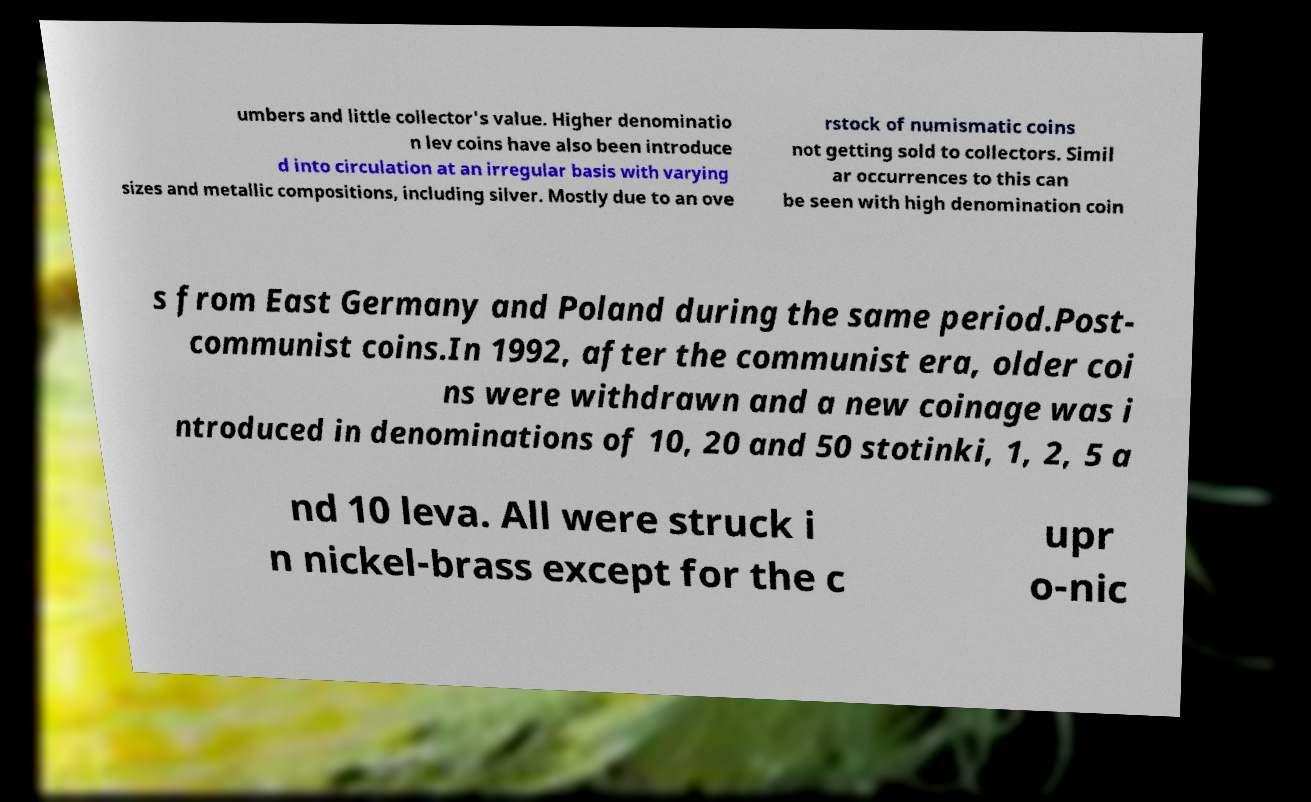Can you read and provide the text displayed in the image?This photo seems to have some interesting text. Can you extract and type it out for me? umbers and little collector's value. Higher denominatio n lev coins have also been introduce d into circulation at an irregular basis with varying sizes and metallic compositions, including silver. Mostly due to an ove rstock of numismatic coins not getting sold to collectors. Simil ar occurrences to this can be seen with high denomination coin s from East Germany and Poland during the same period.Post- communist coins.In 1992, after the communist era, older coi ns were withdrawn and a new coinage was i ntroduced in denominations of 10, 20 and 50 stotinki, 1, 2, 5 a nd 10 leva. All were struck i n nickel-brass except for the c upr o-nic 